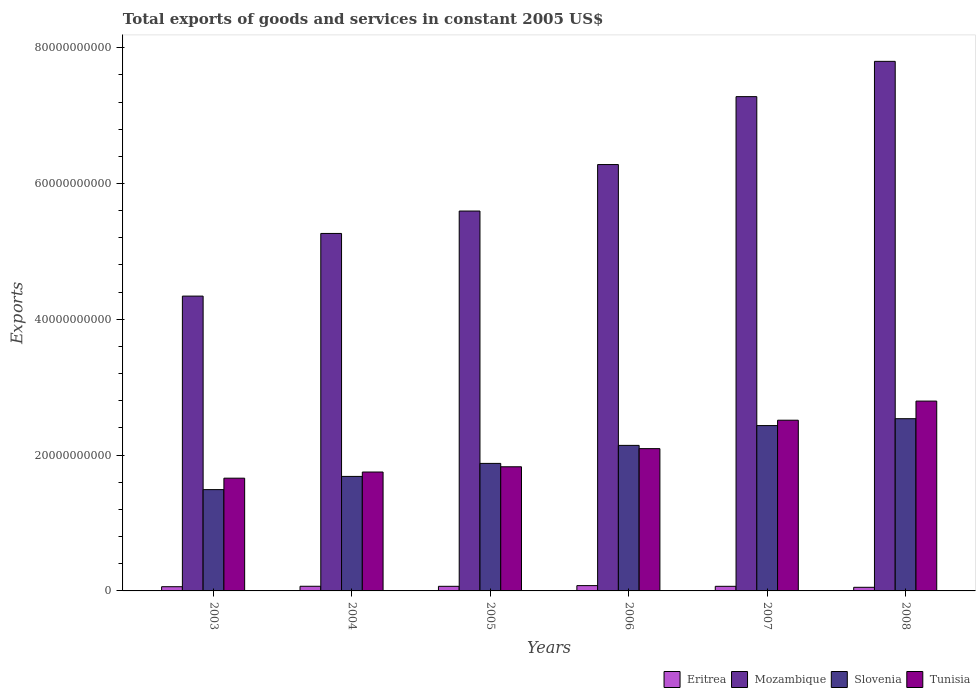How many different coloured bars are there?
Keep it short and to the point. 4. How many groups of bars are there?
Give a very brief answer. 6. Are the number of bars on each tick of the X-axis equal?
Keep it short and to the point. Yes. How many bars are there on the 2nd tick from the left?
Offer a terse response. 4. How many bars are there on the 3rd tick from the right?
Provide a short and direct response. 4. What is the total exports of goods and services in Eritrea in 2007?
Your answer should be very brief. 6.78e+08. Across all years, what is the maximum total exports of goods and services in Mozambique?
Provide a succinct answer. 7.80e+1. Across all years, what is the minimum total exports of goods and services in Eritrea?
Keep it short and to the point. 5.33e+08. In which year was the total exports of goods and services in Eritrea maximum?
Your answer should be compact. 2006. What is the total total exports of goods and services in Eritrea in the graph?
Your answer should be very brief. 3.97e+09. What is the difference between the total exports of goods and services in Eritrea in 2005 and that in 2008?
Provide a succinct answer. 1.45e+08. What is the difference between the total exports of goods and services in Eritrea in 2008 and the total exports of goods and services in Tunisia in 2006?
Give a very brief answer. -2.04e+1. What is the average total exports of goods and services in Eritrea per year?
Your answer should be compact. 6.62e+08. In the year 2007, what is the difference between the total exports of goods and services in Tunisia and total exports of goods and services in Slovenia?
Provide a succinct answer. 7.92e+08. In how many years, is the total exports of goods and services in Mozambique greater than 16000000000 US$?
Offer a very short reply. 6. What is the ratio of the total exports of goods and services in Mozambique in 2005 to that in 2006?
Offer a very short reply. 0.89. Is the total exports of goods and services in Mozambique in 2006 less than that in 2008?
Offer a terse response. Yes. Is the difference between the total exports of goods and services in Tunisia in 2005 and 2007 greater than the difference between the total exports of goods and services in Slovenia in 2005 and 2007?
Provide a short and direct response. No. What is the difference between the highest and the second highest total exports of goods and services in Tunisia?
Provide a short and direct response. 2.82e+09. What is the difference between the highest and the lowest total exports of goods and services in Slovenia?
Offer a terse response. 1.04e+1. In how many years, is the total exports of goods and services in Eritrea greater than the average total exports of goods and services in Eritrea taken over all years?
Offer a terse response. 4. Is it the case that in every year, the sum of the total exports of goods and services in Mozambique and total exports of goods and services in Slovenia is greater than the sum of total exports of goods and services in Eritrea and total exports of goods and services in Tunisia?
Your response must be concise. Yes. What does the 3rd bar from the left in 2004 represents?
Ensure brevity in your answer.  Slovenia. What does the 4th bar from the right in 2007 represents?
Provide a short and direct response. Eritrea. Is it the case that in every year, the sum of the total exports of goods and services in Mozambique and total exports of goods and services in Slovenia is greater than the total exports of goods and services in Eritrea?
Your response must be concise. Yes. How many bars are there?
Your answer should be compact. 24. Are the values on the major ticks of Y-axis written in scientific E-notation?
Your answer should be very brief. No. Does the graph contain any zero values?
Keep it short and to the point. No. Where does the legend appear in the graph?
Your answer should be compact. Bottom right. How are the legend labels stacked?
Offer a terse response. Horizontal. What is the title of the graph?
Give a very brief answer. Total exports of goods and services in constant 2005 US$. Does "Gabon" appear as one of the legend labels in the graph?
Offer a very short reply. No. What is the label or title of the Y-axis?
Provide a succinct answer. Exports. What is the Exports of Eritrea in 2003?
Provide a succinct answer. 6.21e+08. What is the Exports of Mozambique in 2003?
Your response must be concise. 4.34e+1. What is the Exports of Slovenia in 2003?
Give a very brief answer. 1.49e+1. What is the Exports in Tunisia in 2003?
Ensure brevity in your answer.  1.66e+1. What is the Exports of Eritrea in 2004?
Your answer should be very brief. 6.85e+08. What is the Exports in Mozambique in 2004?
Your answer should be compact. 5.26e+1. What is the Exports of Slovenia in 2004?
Ensure brevity in your answer.  1.69e+1. What is the Exports of Tunisia in 2004?
Your response must be concise. 1.75e+1. What is the Exports in Eritrea in 2005?
Give a very brief answer. 6.78e+08. What is the Exports of Mozambique in 2005?
Give a very brief answer. 5.59e+1. What is the Exports in Slovenia in 2005?
Offer a very short reply. 1.88e+1. What is the Exports in Tunisia in 2005?
Offer a very short reply. 1.83e+1. What is the Exports in Eritrea in 2006?
Ensure brevity in your answer.  7.80e+08. What is the Exports of Mozambique in 2006?
Provide a short and direct response. 6.28e+1. What is the Exports of Slovenia in 2006?
Keep it short and to the point. 2.14e+1. What is the Exports in Tunisia in 2006?
Provide a short and direct response. 2.10e+1. What is the Exports of Eritrea in 2007?
Provide a succinct answer. 6.78e+08. What is the Exports in Mozambique in 2007?
Your response must be concise. 7.28e+1. What is the Exports in Slovenia in 2007?
Offer a terse response. 2.44e+1. What is the Exports of Tunisia in 2007?
Keep it short and to the point. 2.51e+1. What is the Exports in Eritrea in 2008?
Keep it short and to the point. 5.33e+08. What is the Exports of Mozambique in 2008?
Provide a succinct answer. 7.80e+1. What is the Exports in Slovenia in 2008?
Make the answer very short. 2.54e+1. What is the Exports in Tunisia in 2008?
Keep it short and to the point. 2.80e+1. Across all years, what is the maximum Exports of Eritrea?
Offer a very short reply. 7.80e+08. Across all years, what is the maximum Exports of Mozambique?
Your answer should be very brief. 7.80e+1. Across all years, what is the maximum Exports of Slovenia?
Offer a very short reply. 2.54e+1. Across all years, what is the maximum Exports in Tunisia?
Your response must be concise. 2.80e+1. Across all years, what is the minimum Exports in Eritrea?
Keep it short and to the point. 5.33e+08. Across all years, what is the minimum Exports in Mozambique?
Your answer should be compact. 4.34e+1. Across all years, what is the minimum Exports in Slovenia?
Your answer should be very brief. 1.49e+1. Across all years, what is the minimum Exports in Tunisia?
Give a very brief answer. 1.66e+1. What is the total Exports of Eritrea in the graph?
Offer a terse response. 3.97e+09. What is the total Exports of Mozambique in the graph?
Your answer should be very brief. 3.66e+11. What is the total Exports in Slovenia in the graph?
Provide a succinct answer. 1.22e+11. What is the total Exports in Tunisia in the graph?
Ensure brevity in your answer.  1.26e+11. What is the difference between the Exports of Eritrea in 2003 and that in 2004?
Provide a short and direct response. -6.41e+07. What is the difference between the Exports in Mozambique in 2003 and that in 2004?
Offer a very short reply. -9.23e+09. What is the difference between the Exports in Slovenia in 2003 and that in 2004?
Give a very brief answer. -1.95e+09. What is the difference between the Exports of Tunisia in 2003 and that in 2004?
Ensure brevity in your answer.  -9.07e+08. What is the difference between the Exports in Eritrea in 2003 and that in 2005?
Your response must be concise. -5.71e+07. What is the difference between the Exports in Mozambique in 2003 and that in 2005?
Provide a succinct answer. -1.25e+1. What is the difference between the Exports in Slovenia in 2003 and that in 2005?
Your answer should be very brief. -3.86e+09. What is the difference between the Exports in Tunisia in 2003 and that in 2005?
Give a very brief answer. -1.68e+09. What is the difference between the Exports of Eritrea in 2003 and that in 2006?
Keep it short and to the point. -1.59e+08. What is the difference between the Exports in Mozambique in 2003 and that in 2006?
Ensure brevity in your answer.  -1.94e+1. What is the difference between the Exports in Slovenia in 2003 and that in 2006?
Keep it short and to the point. -6.51e+09. What is the difference between the Exports in Tunisia in 2003 and that in 2006?
Make the answer very short. -4.35e+09. What is the difference between the Exports of Eritrea in 2003 and that in 2007?
Your answer should be very brief. -5.70e+07. What is the difference between the Exports of Mozambique in 2003 and that in 2007?
Keep it short and to the point. -2.94e+1. What is the difference between the Exports in Slovenia in 2003 and that in 2007?
Offer a very short reply. -9.43e+09. What is the difference between the Exports in Tunisia in 2003 and that in 2007?
Offer a terse response. -8.54e+09. What is the difference between the Exports in Eritrea in 2003 and that in 2008?
Ensure brevity in your answer.  8.79e+07. What is the difference between the Exports of Mozambique in 2003 and that in 2008?
Keep it short and to the point. -3.46e+1. What is the difference between the Exports of Slovenia in 2003 and that in 2008?
Provide a short and direct response. -1.04e+1. What is the difference between the Exports of Tunisia in 2003 and that in 2008?
Provide a succinct answer. -1.14e+1. What is the difference between the Exports of Eritrea in 2004 and that in 2005?
Provide a succinct answer. 7.06e+06. What is the difference between the Exports of Mozambique in 2004 and that in 2005?
Offer a very short reply. -3.30e+09. What is the difference between the Exports in Slovenia in 2004 and that in 2005?
Ensure brevity in your answer.  -1.92e+09. What is the difference between the Exports in Tunisia in 2004 and that in 2005?
Ensure brevity in your answer.  -7.73e+08. What is the difference between the Exports of Eritrea in 2004 and that in 2006?
Offer a very short reply. -9.53e+07. What is the difference between the Exports of Mozambique in 2004 and that in 2006?
Offer a very short reply. -1.01e+1. What is the difference between the Exports of Slovenia in 2004 and that in 2006?
Your answer should be very brief. -4.57e+09. What is the difference between the Exports in Tunisia in 2004 and that in 2006?
Keep it short and to the point. -3.45e+09. What is the difference between the Exports of Eritrea in 2004 and that in 2007?
Provide a succinct answer. 7.15e+06. What is the difference between the Exports in Mozambique in 2004 and that in 2007?
Provide a succinct answer. -2.01e+1. What is the difference between the Exports in Slovenia in 2004 and that in 2007?
Provide a succinct answer. -7.49e+09. What is the difference between the Exports of Tunisia in 2004 and that in 2007?
Give a very brief answer. -7.63e+09. What is the difference between the Exports of Eritrea in 2004 and that in 2008?
Provide a short and direct response. 1.52e+08. What is the difference between the Exports of Mozambique in 2004 and that in 2008?
Offer a terse response. -2.53e+1. What is the difference between the Exports of Slovenia in 2004 and that in 2008?
Offer a very short reply. -8.50e+09. What is the difference between the Exports of Tunisia in 2004 and that in 2008?
Make the answer very short. -1.04e+1. What is the difference between the Exports in Eritrea in 2005 and that in 2006?
Provide a succinct answer. -1.02e+08. What is the difference between the Exports in Mozambique in 2005 and that in 2006?
Give a very brief answer. -6.84e+09. What is the difference between the Exports of Slovenia in 2005 and that in 2006?
Make the answer very short. -2.65e+09. What is the difference between the Exports in Tunisia in 2005 and that in 2006?
Your answer should be compact. -2.67e+09. What is the difference between the Exports of Eritrea in 2005 and that in 2007?
Ensure brevity in your answer.  9.37e+04. What is the difference between the Exports of Mozambique in 2005 and that in 2007?
Offer a terse response. -1.68e+1. What is the difference between the Exports in Slovenia in 2005 and that in 2007?
Your answer should be compact. -5.57e+09. What is the difference between the Exports in Tunisia in 2005 and that in 2007?
Offer a very short reply. -6.86e+09. What is the difference between the Exports of Eritrea in 2005 and that in 2008?
Offer a very short reply. 1.45e+08. What is the difference between the Exports of Mozambique in 2005 and that in 2008?
Make the answer very short. -2.20e+1. What is the difference between the Exports in Slovenia in 2005 and that in 2008?
Offer a terse response. -6.58e+09. What is the difference between the Exports of Tunisia in 2005 and that in 2008?
Your response must be concise. -9.67e+09. What is the difference between the Exports in Eritrea in 2006 and that in 2007?
Provide a succinct answer. 1.02e+08. What is the difference between the Exports in Mozambique in 2006 and that in 2007?
Give a very brief answer. -1.00e+1. What is the difference between the Exports in Slovenia in 2006 and that in 2007?
Give a very brief answer. -2.92e+09. What is the difference between the Exports in Tunisia in 2006 and that in 2007?
Provide a short and direct response. -4.19e+09. What is the difference between the Exports of Eritrea in 2006 and that in 2008?
Keep it short and to the point. 2.47e+08. What is the difference between the Exports in Mozambique in 2006 and that in 2008?
Provide a succinct answer. -1.52e+1. What is the difference between the Exports of Slovenia in 2006 and that in 2008?
Your answer should be very brief. -3.93e+09. What is the difference between the Exports in Tunisia in 2006 and that in 2008?
Provide a short and direct response. -7.00e+09. What is the difference between the Exports of Eritrea in 2007 and that in 2008?
Keep it short and to the point. 1.45e+08. What is the difference between the Exports of Mozambique in 2007 and that in 2008?
Provide a succinct answer. -5.20e+09. What is the difference between the Exports of Slovenia in 2007 and that in 2008?
Provide a short and direct response. -1.01e+09. What is the difference between the Exports of Tunisia in 2007 and that in 2008?
Keep it short and to the point. -2.82e+09. What is the difference between the Exports in Eritrea in 2003 and the Exports in Mozambique in 2004?
Provide a short and direct response. -5.20e+1. What is the difference between the Exports of Eritrea in 2003 and the Exports of Slovenia in 2004?
Provide a short and direct response. -1.62e+1. What is the difference between the Exports in Eritrea in 2003 and the Exports in Tunisia in 2004?
Your answer should be very brief. -1.69e+1. What is the difference between the Exports of Mozambique in 2003 and the Exports of Slovenia in 2004?
Your response must be concise. 2.66e+1. What is the difference between the Exports of Mozambique in 2003 and the Exports of Tunisia in 2004?
Provide a succinct answer. 2.59e+1. What is the difference between the Exports of Slovenia in 2003 and the Exports of Tunisia in 2004?
Your answer should be compact. -2.59e+09. What is the difference between the Exports of Eritrea in 2003 and the Exports of Mozambique in 2005?
Give a very brief answer. -5.53e+1. What is the difference between the Exports in Eritrea in 2003 and the Exports in Slovenia in 2005?
Your answer should be very brief. -1.82e+1. What is the difference between the Exports of Eritrea in 2003 and the Exports of Tunisia in 2005?
Provide a succinct answer. -1.77e+1. What is the difference between the Exports of Mozambique in 2003 and the Exports of Slovenia in 2005?
Keep it short and to the point. 2.46e+1. What is the difference between the Exports in Mozambique in 2003 and the Exports in Tunisia in 2005?
Your response must be concise. 2.51e+1. What is the difference between the Exports of Slovenia in 2003 and the Exports of Tunisia in 2005?
Make the answer very short. -3.36e+09. What is the difference between the Exports in Eritrea in 2003 and the Exports in Mozambique in 2006?
Your answer should be compact. -6.22e+1. What is the difference between the Exports in Eritrea in 2003 and the Exports in Slovenia in 2006?
Give a very brief answer. -2.08e+1. What is the difference between the Exports in Eritrea in 2003 and the Exports in Tunisia in 2006?
Give a very brief answer. -2.03e+1. What is the difference between the Exports of Mozambique in 2003 and the Exports of Slovenia in 2006?
Your response must be concise. 2.20e+1. What is the difference between the Exports of Mozambique in 2003 and the Exports of Tunisia in 2006?
Offer a terse response. 2.25e+1. What is the difference between the Exports of Slovenia in 2003 and the Exports of Tunisia in 2006?
Your answer should be compact. -6.04e+09. What is the difference between the Exports in Eritrea in 2003 and the Exports in Mozambique in 2007?
Provide a short and direct response. -7.22e+1. What is the difference between the Exports of Eritrea in 2003 and the Exports of Slovenia in 2007?
Provide a short and direct response. -2.37e+1. What is the difference between the Exports of Eritrea in 2003 and the Exports of Tunisia in 2007?
Make the answer very short. -2.45e+1. What is the difference between the Exports in Mozambique in 2003 and the Exports in Slovenia in 2007?
Your answer should be very brief. 1.91e+1. What is the difference between the Exports of Mozambique in 2003 and the Exports of Tunisia in 2007?
Give a very brief answer. 1.83e+1. What is the difference between the Exports of Slovenia in 2003 and the Exports of Tunisia in 2007?
Offer a terse response. -1.02e+1. What is the difference between the Exports of Eritrea in 2003 and the Exports of Mozambique in 2008?
Offer a very short reply. -7.74e+1. What is the difference between the Exports of Eritrea in 2003 and the Exports of Slovenia in 2008?
Your response must be concise. -2.47e+1. What is the difference between the Exports of Eritrea in 2003 and the Exports of Tunisia in 2008?
Ensure brevity in your answer.  -2.73e+1. What is the difference between the Exports in Mozambique in 2003 and the Exports in Slovenia in 2008?
Provide a short and direct response. 1.81e+1. What is the difference between the Exports of Mozambique in 2003 and the Exports of Tunisia in 2008?
Your answer should be very brief. 1.55e+1. What is the difference between the Exports of Slovenia in 2003 and the Exports of Tunisia in 2008?
Ensure brevity in your answer.  -1.30e+1. What is the difference between the Exports of Eritrea in 2004 and the Exports of Mozambique in 2005?
Your response must be concise. -5.53e+1. What is the difference between the Exports of Eritrea in 2004 and the Exports of Slovenia in 2005?
Ensure brevity in your answer.  -1.81e+1. What is the difference between the Exports of Eritrea in 2004 and the Exports of Tunisia in 2005?
Your response must be concise. -1.76e+1. What is the difference between the Exports in Mozambique in 2004 and the Exports in Slovenia in 2005?
Your response must be concise. 3.39e+1. What is the difference between the Exports of Mozambique in 2004 and the Exports of Tunisia in 2005?
Keep it short and to the point. 3.44e+1. What is the difference between the Exports of Slovenia in 2004 and the Exports of Tunisia in 2005?
Give a very brief answer. -1.42e+09. What is the difference between the Exports in Eritrea in 2004 and the Exports in Mozambique in 2006?
Offer a terse response. -6.21e+1. What is the difference between the Exports in Eritrea in 2004 and the Exports in Slovenia in 2006?
Provide a short and direct response. -2.07e+1. What is the difference between the Exports in Eritrea in 2004 and the Exports in Tunisia in 2006?
Give a very brief answer. -2.03e+1. What is the difference between the Exports of Mozambique in 2004 and the Exports of Slovenia in 2006?
Offer a terse response. 3.12e+1. What is the difference between the Exports of Mozambique in 2004 and the Exports of Tunisia in 2006?
Your response must be concise. 3.17e+1. What is the difference between the Exports of Slovenia in 2004 and the Exports of Tunisia in 2006?
Give a very brief answer. -4.09e+09. What is the difference between the Exports in Eritrea in 2004 and the Exports in Mozambique in 2007?
Offer a very short reply. -7.21e+1. What is the difference between the Exports of Eritrea in 2004 and the Exports of Slovenia in 2007?
Provide a succinct answer. -2.37e+1. What is the difference between the Exports of Eritrea in 2004 and the Exports of Tunisia in 2007?
Offer a very short reply. -2.45e+1. What is the difference between the Exports of Mozambique in 2004 and the Exports of Slovenia in 2007?
Make the answer very short. 2.83e+1. What is the difference between the Exports of Mozambique in 2004 and the Exports of Tunisia in 2007?
Give a very brief answer. 2.75e+1. What is the difference between the Exports of Slovenia in 2004 and the Exports of Tunisia in 2007?
Provide a succinct answer. -8.28e+09. What is the difference between the Exports of Eritrea in 2004 and the Exports of Mozambique in 2008?
Make the answer very short. -7.73e+1. What is the difference between the Exports in Eritrea in 2004 and the Exports in Slovenia in 2008?
Your response must be concise. -2.47e+1. What is the difference between the Exports of Eritrea in 2004 and the Exports of Tunisia in 2008?
Make the answer very short. -2.73e+1. What is the difference between the Exports of Mozambique in 2004 and the Exports of Slovenia in 2008?
Provide a succinct answer. 2.73e+1. What is the difference between the Exports of Mozambique in 2004 and the Exports of Tunisia in 2008?
Offer a very short reply. 2.47e+1. What is the difference between the Exports in Slovenia in 2004 and the Exports in Tunisia in 2008?
Make the answer very short. -1.11e+1. What is the difference between the Exports in Eritrea in 2005 and the Exports in Mozambique in 2006?
Offer a terse response. -6.21e+1. What is the difference between the Exports of Eritrea in 2005 and the Exports of Slovenia in 2006?
Make the answer very short. -2.08e+1. What is the difference between the Exports in Eritrea in 2005 and the Exports in Tunisia in 2006?
Ensure brevity in your answer.  -2.03e+1. What is the difference between the Exports of Mozambique in 2005 and the Exports of Slovenia in 2006?
Your answer should be compact. 3.45e+1. What is the difference between the Exports of Mozambique in 2005 and the Exports of Tunisia in 2006?
Ensure brevity in your answer.  3.50e+1. What is the difference between the Exports in Slovenia in 2005 and the Exports in Tunisia in 2006?
Ensure brevity in your answer.  -2.17e+09. What is the difference between the Exports in Eritrea in 2005 and the Exports in Mozambique in 2007?
Provide a succinct answer. -7.21e+1. What is the difference between the Exports in Eritrea in 2005 and the Exports in Slovenia in 2007?
Provide a succinct answer. -2.37e+1. What is the difference between the Exports of Eritrea in 2005 and the Exports of Tunisia in 2007?
Ensure brevity in your answer.  -2.45e+1. What is the difference between the Exports in Mozambique in 2005 and the Exports in Slovenia in 2007?
Ensure brevity in your answer.  3.16e+1. What is the difference between the Exports of Mozambique in 2005 and the Exports of Tunisia in 2007?
Your response must be concise. 3.08e+1. What is the difference between the Exports of Slovenia in 2005 and the Exports of Tunisia in 2007?
Keep it short and to the point. -6.36e+09. What is the difference between the Exports of Eritrea in 2005 and the Exports of Mozambique in 2008?
Keep it short and to the point. -7.73e+1. What is the difference between the Exports of Eritrea in 2005 and the Exports of Slovenia in 2008?
Make the answer very short. -2.47e+1. What is the difference between the Exports of Eritrea in 2005 and the Exports of Tunisia in 2008?
Offer a very short reply. -2.73e+1. What is the difference between the Exports in Mozambique in 2005 and the Exports in Slovenia in 2008?
Offer a terse response. 3.06e+1. What is the difference between the Exports in Mozambique in 2005 and the Exports in Tunisia in 2008?
Ensure brevity in your answer.  2.80e+1. What is the difference between the Exports of Slovenia in 2005 and the Exports of Tunisia in 2008?
Your answer should be very brief. -9.18e+09. What is the difference between the Exports of Eritrea in 2006 and the Exports of Mozambique in 2007?
Provide a short and direct response. -7.20e+1. What is the difference between the Exports of Eritrea in 2006 and the Exports of Slovenia in 2007?
Your response must be concise. -2.36e+1. What is the difference between the Exports of Eritrea in 2006 and the Exports of Tunisia in 2007?
Give a very brief answer. -2.44e+1. What is the difference between the Exports in Mozambique in 2006 and the Exports in Slovenia in 2007?
Provide a succinct answer. 3.84e+1. What is the difference between the Exports in Mozambique in 2006 and the Exports in Tunisia in 2007?
Your answer should be compact. 3.76e+1. What is the difference between the Exports of Slovenia in 2006 and the Exports of Tunisia in 2007?
Give a very brief answer. -3.71e+09. What is the difference between the Exports of Eritrea in 2006 and the Exports of Mozambique in 2008?
Keep it short and to the point. -7.72e+1. What is the difference between the Exports in Eritrea in 2006 and the Exports in Slovenia in 2008?
Give a very brief answer. -2.46e+1. What is the difference between the Exports of Eritrea in 2006 and the Exports of Tunisia in 2008?
Ensure brevity in your answer.  -2.72e+1. What is the difference between the Exports in Mozambique in 2006 and the Exports in Slovenia in 2008?
Keep it short and to the point. 3.74e+1. What is the difference between the Exports in Mozambique in 2006 and the Exports in Tunisia in 2008?
Provide a short and direct response. 3.48e+1. What is the difference between the Exports in Slovenia in 2006 and the Exports in Tunisia in 2008?
Your answer should be compact. -6.52e+09. What is the difference between the Exports of Eritrea in 2007 and the Exports of Mozambique in 2008?
Provide a succinct answer. -7.73e+1. What is the difference between the Exports in Eritrea in 2007 and the Exports in Slovenia in 2008?
Provide a succinct answer. -2.47e+1. What is the difference between the Exports of Eritrea in 2007 and the Exports of Tunisia in 2008?
Ensure brevity in your answer.  -2.73e+1. What is the difference between the Exports in Mozambique in 2007 and the Exports in Slovenia in 2008?
Your answer should be very brief. 4.74e+1. What is the difference between the Exports in Mozambique in 2007 and the Exports in Tunisia in 2008?
Your answer should be very brief. 4.48e+1. What is the difference between the Exports of Slovenia in 2007 and the Exports of Tunisia in 2008?
Your response must be concise. -3.61e+09. What is the average Exports of Eritrea per year?
Your response must be concise. 6.62e+08. What is the average Exports in Mozambique per year?
Keep it short and to the point. 6.09e+1. What is the average Exports of Slovenia per year?
Ensure brevity in your answer.  2.03e+1. What is the average Exports of Tunisia per year?
Make the answer very short. 2.11e+1. In the year 2003, what is the difference between the Exports in Eritrea and Exports in Mozambique?
Keep it short and to the point. -4.28e+1. In the year 2003, what is the difference between the Exports of Eritrea and Exports of Slovenia?
Your response must be concise. -1.43e+1. In the year 2003, what is the difference between the Exports of Eritrea and Exports of Tunisia?
Your answer should be very brief. -1.60e+1. In the year 2003, what is the difference between the Exports in Mozambique and Exports in Slovenia?
Your response must be concise. 2.85e+1. In the year 2003, what is the difference between the Exports in Mozambique and Exports in Tunisia?
Provide a succinct answer. 2.68e+1. In the year 2003, what is the difference between the Exports of Slovenia and Exports of Tunisia?
Your answer should be very brief. -1.68e+09. In the year 2004, what is the difference between the Exports of Eritrea and Exports of Mozambique?
Keep it short and to the point. -5.20e+1. In the year 2004, what is the difference between the Exports in Eritrea and Exports in Slovenia?
Your answer should be very brief. -1.62e+1. In the year 2004, what is the difference between the Exports in Eritrea and Exports in Tunisia?
Ensure brevity in your answer.  -1.68e+1. In the year 2004, what is the difference between the Exports of Mozambique and Exports of Slovenia?
Provide a short and direct response. 3.58e+1. In the year 2004, what is the difference between the Exports of Mozambique and Exports of Tunisia?
Provide a succinct answer. 3.51e+1. In the year 2004, what is the difference between the Exports in Slovenia and Exports in Tunisia?
Offer a terse response. -6.45e+08. In the year 2005, what is the difference between the Exports in Eritrea and Exports in Mozambique?
Provide a succinct answer. -5.53e+1. In the year 2005, what is the difference between the Exports of Eritrea and Exports of Slovenia?
Make the answer very short. -1.81e+1. In the year 2005, what is the difference between the Exports in Eritrea and Exports in Tunisia?
Make the answer very short. -1.76e+1. In the year 2005, what is the difference between the Exports in Mozambique and Exports in Slovenia?
Give a very brief answer. 3.72e+1. In the year 2005, what is the difference between the Exports in Mozambique and Exports in Tunisia?
Give a very brief answer. 3.77e+1. In the year 2005, what is the difference between the Exports in Slovenia and Exports in Tunisia?
Make the answer very short. 4.98e+08. In the year 2006, what is the difference between the Exports in Eritrea and Exports in Mozambique?
Your answer should be compact. -6.20e+1. In the year 2006, what is the difference between the Exports in Eritrea and Exports in Slovenia?
Provide a succinct answer. -2.07e+1. In the year 2006, what is the difference between the Exports of Eritrea and Exports of Tunisia?
Your response must be concise. -2.02e+1. In the year 2006, what is the difference between the Exports of Mozambique and Exports of Slovenia?
Your answer should be very brief. 4.14e+1. In the year 2006, what is the difference between the Exports in Mozambique and Exports in Tunisia?
Your answer should be very brief. 4.18e+1. In the year 2006, what is the difference between the Exports in Slovenia and Exports in Tunisia?
Your answer should be compact. 4.78e+08. In the year 2007, what is the difference between the Exports in Eritrea and Exports in Mozambique?
Give a very brief answer. -7.21e+1. In the year 2007, what is the difference between the Exports in Eritrea and Exports in Slovenia?
Offer a very short reply. -2.37e+1. In the year 2007, what is the difference between the Exports of Eritrea and Exports of Tunisia?
Your answer should be compact. -2.45e+1. In the year 2007, what is the difference between the Exports of Mozambique and Exports of Slovenia?
Provide a short and direct response. 4.84e+1. In the year 2007, what is the difference between the Exports in Mozambique and Exports in Tunisia?
Provide a succinct answer. 4.77e+1. In the year 2007, what is the difference between the Exports of Slovenia and Exports of Tunisia?
Offer a very short reply. -7.92e+08. In the year 2008, what is the difference between the Exports of Eritrea and Exports of Mozambique?
Provide a short and direct response. -7.75e+1. In the year 2008, what is the difference between the Exports of Eritrea and Exports of Slovenia?
Ensure brevity in your answer.  -2.48e+1. In the year 2008, what is the difference between the Exports in Eritrea and Exports in Tunisia?
Make the answer very short. -2.74e+1. In the year 2008, what is the difference between the Exports of Mozambique and Exports of Slovenia?
Provide a succinct answer. 5.26e+1. In the year 2008, what is the difference between the Exports of Mozambique and Exports of Tunisia?
Keep it short and to the point. 5.00e+1. In the year 2008, what is the difference between the Exports in Slovenia and Exports in Tunisia?
Your answer should be very brief. -2.59e+09. What is the ratio of the Exports in Eritrea in 2003 to that in 2004?
Provide a succinct answer. 0.91. What is the ratio of the Exports in Mozambique in 2003 to that in 2004?
Make the answer very short. 0.82. What is the ratio of the Exports in Slovenia in 2003 to that in 2004?
Offer a terse response. 0.88. What is the ratio of the Exports in Tunisia in 2003 to that in 2004?
Keep it short and to the point. 0.95. What is the ratio of the Exports of Eritrea in 2003 to that in 2005?
Your answer should be compact. 0.92. What is the ratio of the Exports in Mozambique in 2003 to that in 2005?
Make the answer very short. 0.78. What is the ratio of the Exports of Slovenia in 2003 to that in 2005?
Your response must be concise. 0.79. What is the ratio of the Exports in Tunisia in 2003 to that in 2005?
Provide a short and direct response. 0.91. What is the ratio of the Exports in Eritrea in 2003 to that in 2006?
Give a very brief answer. 0.8. What is the ratio of the Exports in Mozambique in 2003 to that in 2006?
Provide a short and direct response. 0.69. What is the ratio of the Exports of Slovenia in 2003 to that in 2006?
Provide a short and direct response. 0.7. What is the ratio of the Exports in Tunisia in 2003 to that in 2006?
Your answer should be very brief. 0.79. What is the ratio of the Exports in Eritrea in 2003 to that in 2007?
Your answer should be very brief. 0.92. What is the ratio of the Exports in Mozambique in 2003 to that in 2007?
Offer a terse response. 0.6. What is the ratio of the Exports of Slovenia in 2003 to that in 2007?
Give a very brief answer. 0.61. What is the ratio of the Exports in Tunisia in 2003 to that in 2007?
Offer a terse response. 0.66. What is the ratio of the Exports of Eritrea in 2003 to that in 2008?
Your answer should be very brief. 1.16. What is the ratio of the Exports in Mozambique in 2003 to that in 2008?
Give a very brief answer. 0.56. What is the ratio of the Exports of Slovenia in 2003 to that in 2008?
Keep it short and to the point. 0.59. What is the ratio of the Exports in Tunisia in 2003 to that in 2008?
Offer a terse response. 0.59. What is the ratio of the Exports of Eritrea in 2004 to that in 2005?
Make the answer very short. 1.01. What is the ratio of the Exports of Mozambique in 2004 to that in 2005?
Offer a very short reply. 0.94. What is the ratio of the Exports of Slovenia in 2004 to that in 2005?
Offer a terse response. 0.9. What is the ratio of the Exports of Tunisia in 2004 to that in 2005?
Keep it short and to the point. 0.96. What is the ratio of the Exports of Eritrea in 2004 to that in 2006?
Your response must be concise. 0.88. What is the ratio of the Exports in Mozambique in 2004 to that in 2006?
Offer a very short reply. 0.84. What is the ratio of the Exports in Slovenia in 2004 to that in 2006?
Keep it short and to the point. 0.79. What is the ratio of the Exports in Tunisia in 2004 to that in 2006?
Keep it short and to the point. 0.84. What is the ratio of the Exports in Eritrea in 2004 to that in 2007?
Provide a short and direct response. 1.01. What is the ratio of the Exports in Mozambique in 2004 to that in 2007?
Your answer should be compact. 0.72. What is the ratio of the Exports in Slovenia in 2004 to that in 2007?
Offer a terse response. 0.69. What is the ratio of the Exports in Tunisia in 2004 to that in 2007?
Offer a terse response. 0.7. What is the ratio of the Exports in Eritrea in 2004 to that in 2008?
Your answer should be compact. 1.29. What is the ratio of the Exports of Mozambique in 2004 to that in 2008?
Your answer should be very brief. 0.68. What is the ratio of the Exports in Slovenia in 2004 to that in 2008?
Offer a very short reply. 0.66. What is the ratio of the Exports of Tunisia in 2004 to that in 2008?
Provide a succinct answer. 0.63. What is the ratio of the Exports in Eritrea in 2005 to that in 2006?
Offer a terse response. 0.87. What is the ratio of the Exports of Mozambique in 2005 to that in 2006?
Offer a very short reply. 0.89. What is the ratio of the Exports of Slovenia in 2005 to that in 2006?
Provide a short and direct response. 0.88. What is the ratio of the Exports in Tunisia in 2005 to that in 2006?
Give a very brief answer. 0.87. What is the ratio of the Exports of Mozambique in 2005 to that in 2007?
Offer a terse response. 0.77. What is the ratio of the Exports in Slovenia in 2005 to that in 2007?
Provide a succinct answer. 0.77. What is the ratio of the Exports in Tunisia in 2005 to that in 2007?
Your answer should be compact. 0.73. What is the ratio of the Exports of Eritrea in 2005 to that in 2008?
Your response must be concise. 1.27. What is the ratio of the Exports of Mozambique in 2005 to that in 2008?
Keep it short and to the point. 0.72. What is the ratio of the Exports of Slovenia in 2005 to that in 2008?
Make the answer very short. 0.74. What is the ratio of the Exports in Tunisia in 2005 to that in 2008?
Ensure brevity in your answer.  0.65. What is the ratio of the Exports of Eritrea in 2006 to that in 2007?
Keep it short and to the point. 1.15. What is the ratio of the Exports of Mozambique in 2006 to that in 2007?
Your response must be concise. 0.86. What is the ratio of the Exports of Slovenia in 2006 to that in 2007?
Provide a short and direct response. 0.88. What is the ratio of the Exports of Tunisia in 2006 to that in 2007?
Provide a succinct answer. 0.83. What is the ratio of the Exports in Eritrea in 2006 to that in 2008?
Provide a short and direct response. 1.46. What is the ratio of the Exports of Mozambique in 2006 to that in 2008?
Give a very brief answer. 0.81. What is the ratio of the Exports of Slovenia in 2006 to that in 2008?
Offer a very short reply. 0.84. What is the ratio of the Exports of Tunisia in 2006 to that in 2008?
Provide a short and direct response. 0.75. What is the ratio of the Exports of Eritrea in 2007 to that in 2008?
Offer a very short reply. 1.27. What is the ratio of the Exports in Mozambique in 2007 to that in 2008?
Provide a short and direct response. 0.93. What is the ratio of the Exports in Slovenia in 2007 to that in 2008?
Ensure brevity in your answer.  0.96. What is the ratio of the Exports in Tunisia in 2007 to that in 2008?
Make the answer very short. 0.9. What is the difference between the highest and the second highest Exports in Eritrea?
Make the answer very short. 9.53e+07. What is the difference between the highest and the second highest Exports in Mozambique?
Offer a very short reply. 5.20e+09. What is the difference between the highest and the second highest Exports in Slovenia?
Provide a short and direct response. 1.01e+09. What is the difference between the highest and the second highest Exports in Tunisia?
Your response must be concise. 2.82e+09. What is the difference between the highest and the lowest Exports in Eritrea?
Offer a very short reply. 2.47e+08. What is the difference between the highest and the lowest Exports in Mozambique?
Make the answer very short. 3.46e+1. What is the difference between the highest and the lowest Exports in Slovenia?
Make the answer very short. 1.04e+1. What is the difference between the highest and the lowest Exports of Tunisia?
Offer a terse response. 1.14e+1. 